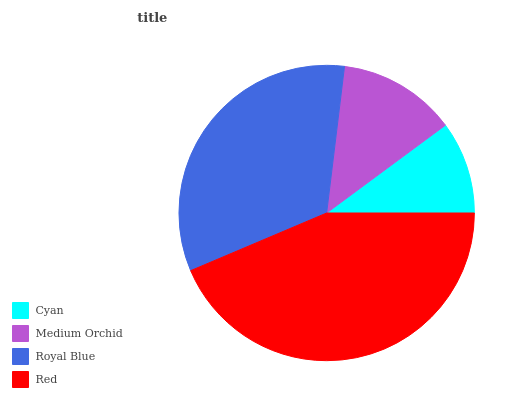Is Cyan the minimum?
Answer yes or no. Yes. Is Red the maximum?
Answer yes or no. Yes. Is Medium Orchid the minimum?
Answer yes or no. No. Is Medium Orchid the maximum?
Answer yes or no. No. Is Medium Orchid greater than Cyan?
Answer yes or no. Yes. Is Cyan less than Medium Orchid?
Answer yes or no. Yes. Is Cyan greater than Medium Orchid?
Answer yes or no. No. Is Medium Orchid less than Cyan?
Answer yes or no. No. Is Royal Blue the high median?
Answer yes or no. Yes. Is Medium Orchid the low median?
Answer yes or no. Yes. Is Red the high median?
Answer yes or no. No. Is Royal Blue the low median?
Answer yes or no. No. 